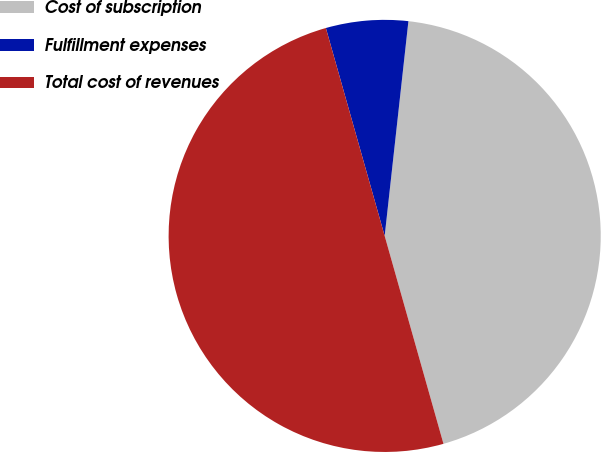Convert chart. <chart><loc_0><loc_0><loc_500><loc_500><pie_chart><fcel>Cost of subscription<fcel>Fulfillment expenses<fcel>Total cost of revenues<nl><fcel>43.86%<fcel>6.14%<fcel>50.0%<nl></chart> 